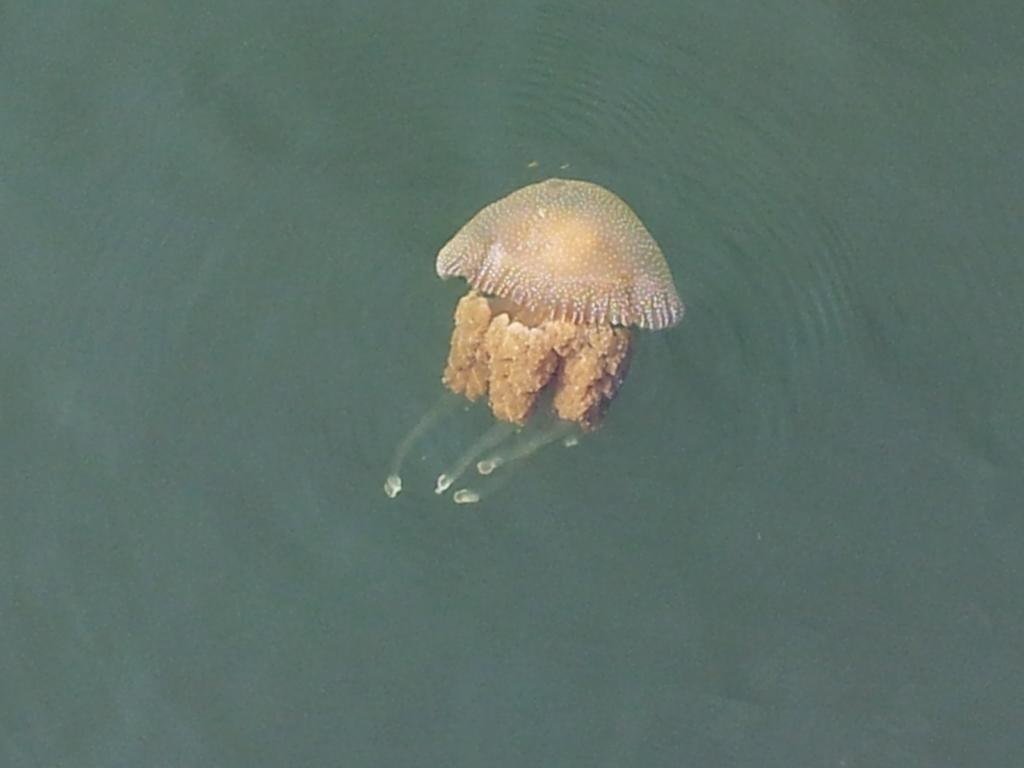What type of animal is in the image? There is an aquatic animal in the image. What color is the aquatic animal? The aquatic animal is brown in color. Where is the animal located in the image? The animal is in the water. What color is the water in the image? The water in the image is green in color. What type of pie is being served on the sponge in the image? There is no pie or sponge present in the image; it features an aquatic animal in green water. 